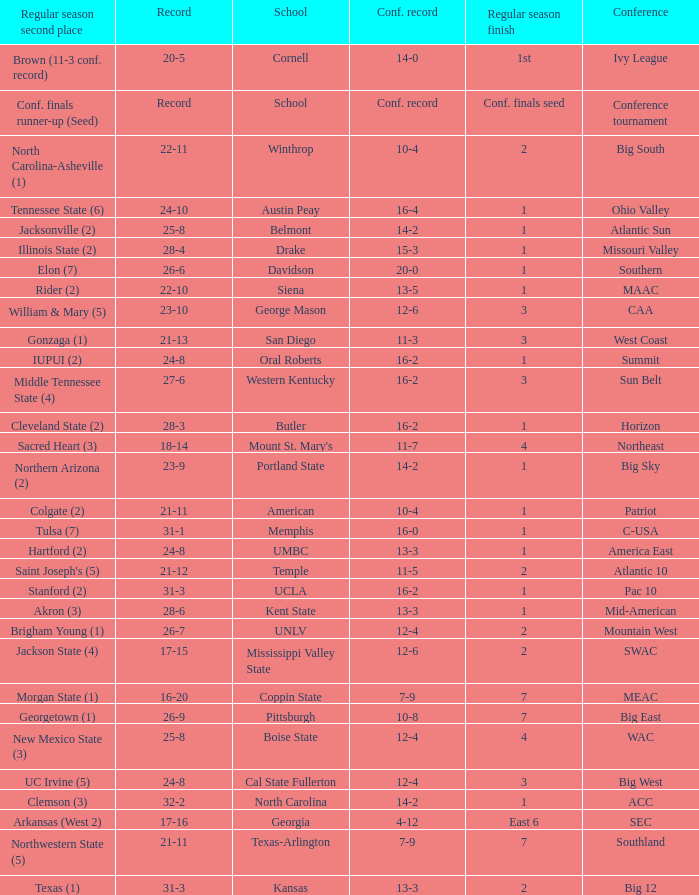What was the overall record of Oral Roberts college? 24-8. 